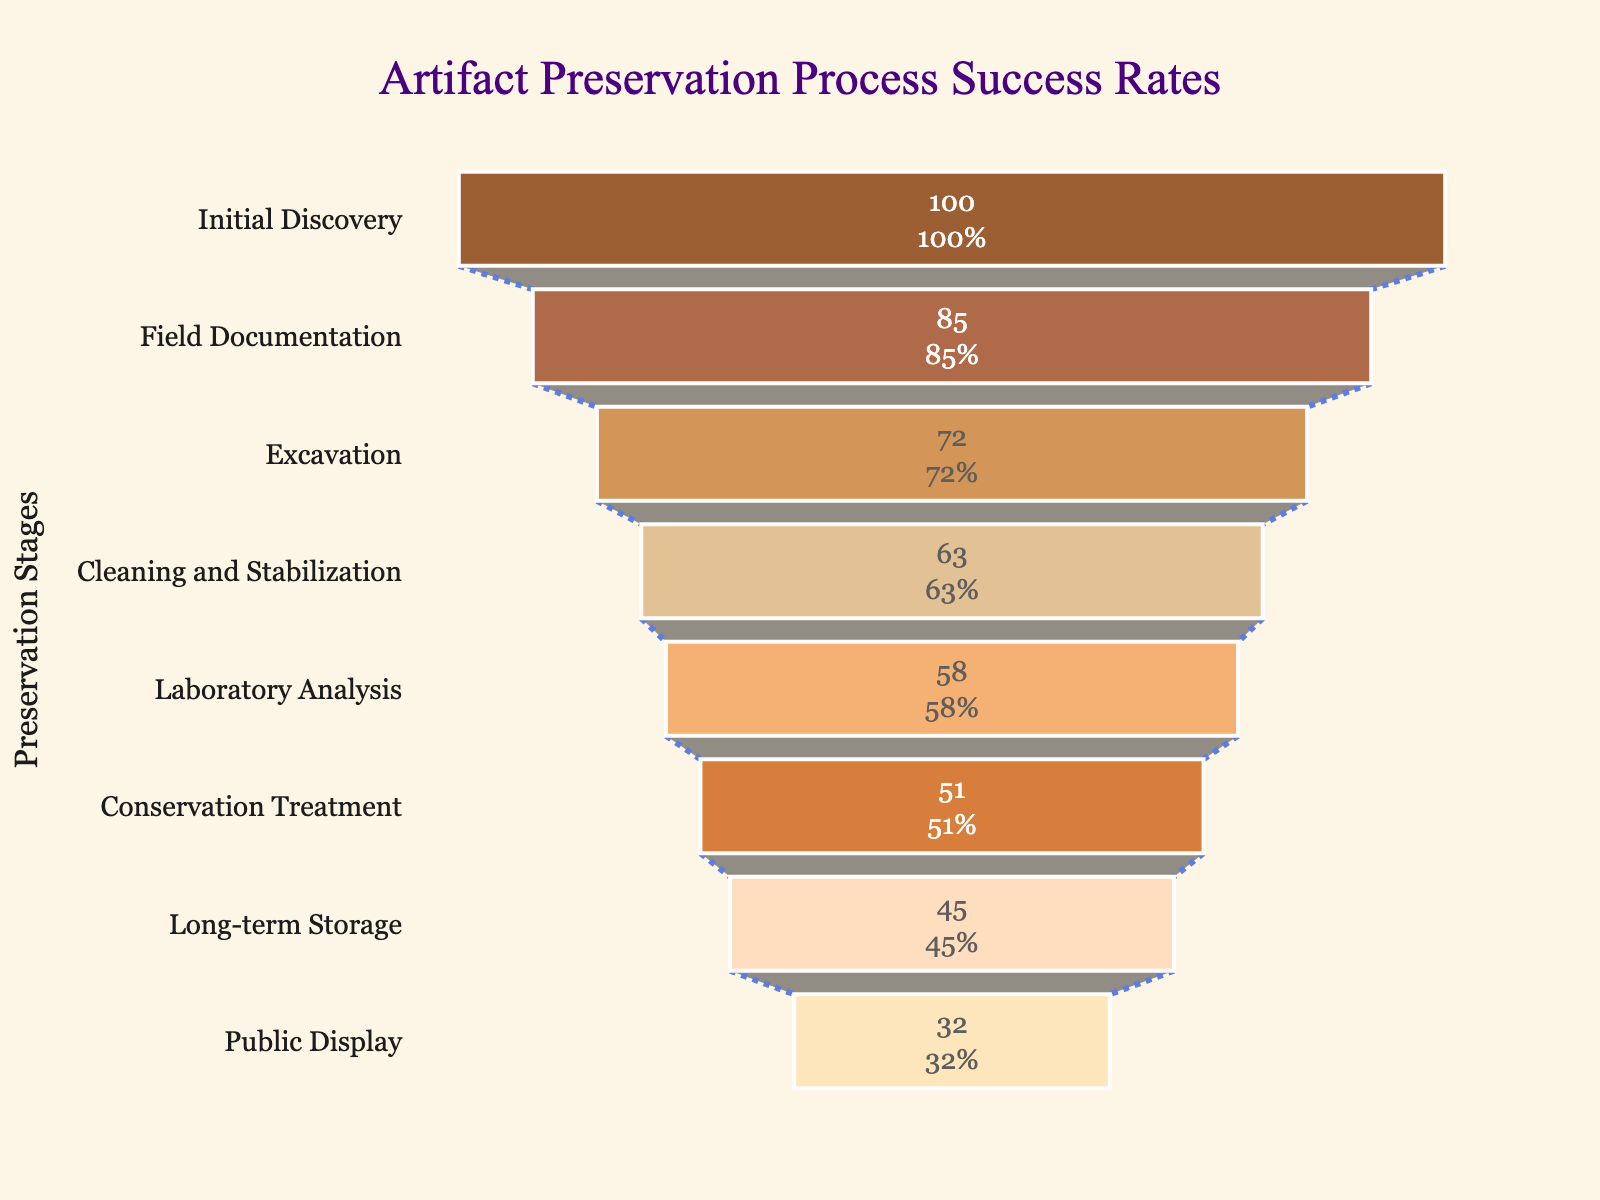What is the title of the chart? The title of the chart is displayed at the top of the figure, in a larger font size and a distinct color. It reads "Artifact Preservation Process Success Rates".
Answer: Artifact Preservation Process Success Rates How many stages are represented in the funnel chart? Count the number of different stages listed on the y-axis of the chart from top to bottom. There are 8 stages displayed in the chart.
Answer: 8 Which stage has the highest success rate? Look at the "Success Rate" values for each stage. The stage at the top with 100% success rate is "Initial Discovery".
Answer: Initial Discovery What is the success rate of the "Public Display" stage? Locate the "Public Display" stage on the y-axis and read the corresponding "Success Rate" value from the x-axis, which is 32%.
Answer: 32% What is the difference in success rates between "Initial Discovery" and "Field Documentation"? Subtract the success rate of "Field Documentation" (85%) from "Initial Discovery" (100%). 100 - 85 = 15.
Answer: 15% Which has a lower success rate: "Laboratory Analysis" or "Conservation Treatment"? Compare the "Success Rate" values for "Laboratory Analysis" (58%) and "Conservation Treatment" (51%). "Conservation Treatment" has a lower success rate.
Answer: Conservation Treatment What percentage of artifacts make it through from "Initial Discovery" to "Long-term Storage"? Read the success rate values for "Initial Discovery" (100%) and "Long-term Storage" (45%). Thus, 45% make it through.
Answer: 45% What happens to the success rate as artifacts move through the preservation stages? Observe the trend of the "Success Rate" values as you move down the stages on the y-axis. The success rate consistently decreases from one stage to the next.
Answer: Decreases Which two stages have the smallest difference in their success rates? Calculate the differences between successive stages: 
Initial Discovery and Field Documentation: 100 - 85 = 15
Field Documentation and Excavation: 85 - 72 = 13
Excavation and Cleaning and Stabilization: 72 - 63 = 9
Cleaning and Stabilization and Laboratory Analysis: 63 - 58 = 5
Laboratory Analysis and Conservation Treatment: 58 - 51 = 7
Conservation Treatment and Long-term Storage: 51 - 45 = 6
Long-term Storage and Public Display: 45 - 32 = 13.
The smallest difference is between "Cleaning and Stabilization" and "Laboratory Analysis" stages (5%).
Answer: Cleaning and Stabilization and Laboratory Analysis By how much does the success rate drop from "Cleaning and Stabilization" to "Laboratory Analysis"? The success rate for "Cleaning and Stabilization" is 63%, and for "Laboratory Analysis" it is 58%. Subtract 58 from 63, which results in a drop of 5%.
Answer: 5% 